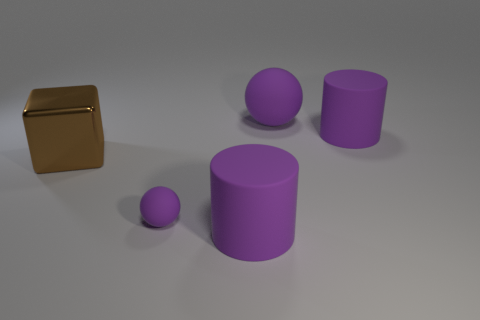Add 1 big matte things. How many objects exist? 6 Subtract 0 brown balls. How many objects are left? 5 Subtract all blocks. How many objects are left? 4 Subtract all purple balls. Subtract all large yellow matte balls. How many objects are left? 3 Add 5 cubes. How many cubes are left? 6 Add 2 big brown matte things. How many big brown matte things exist? 2 